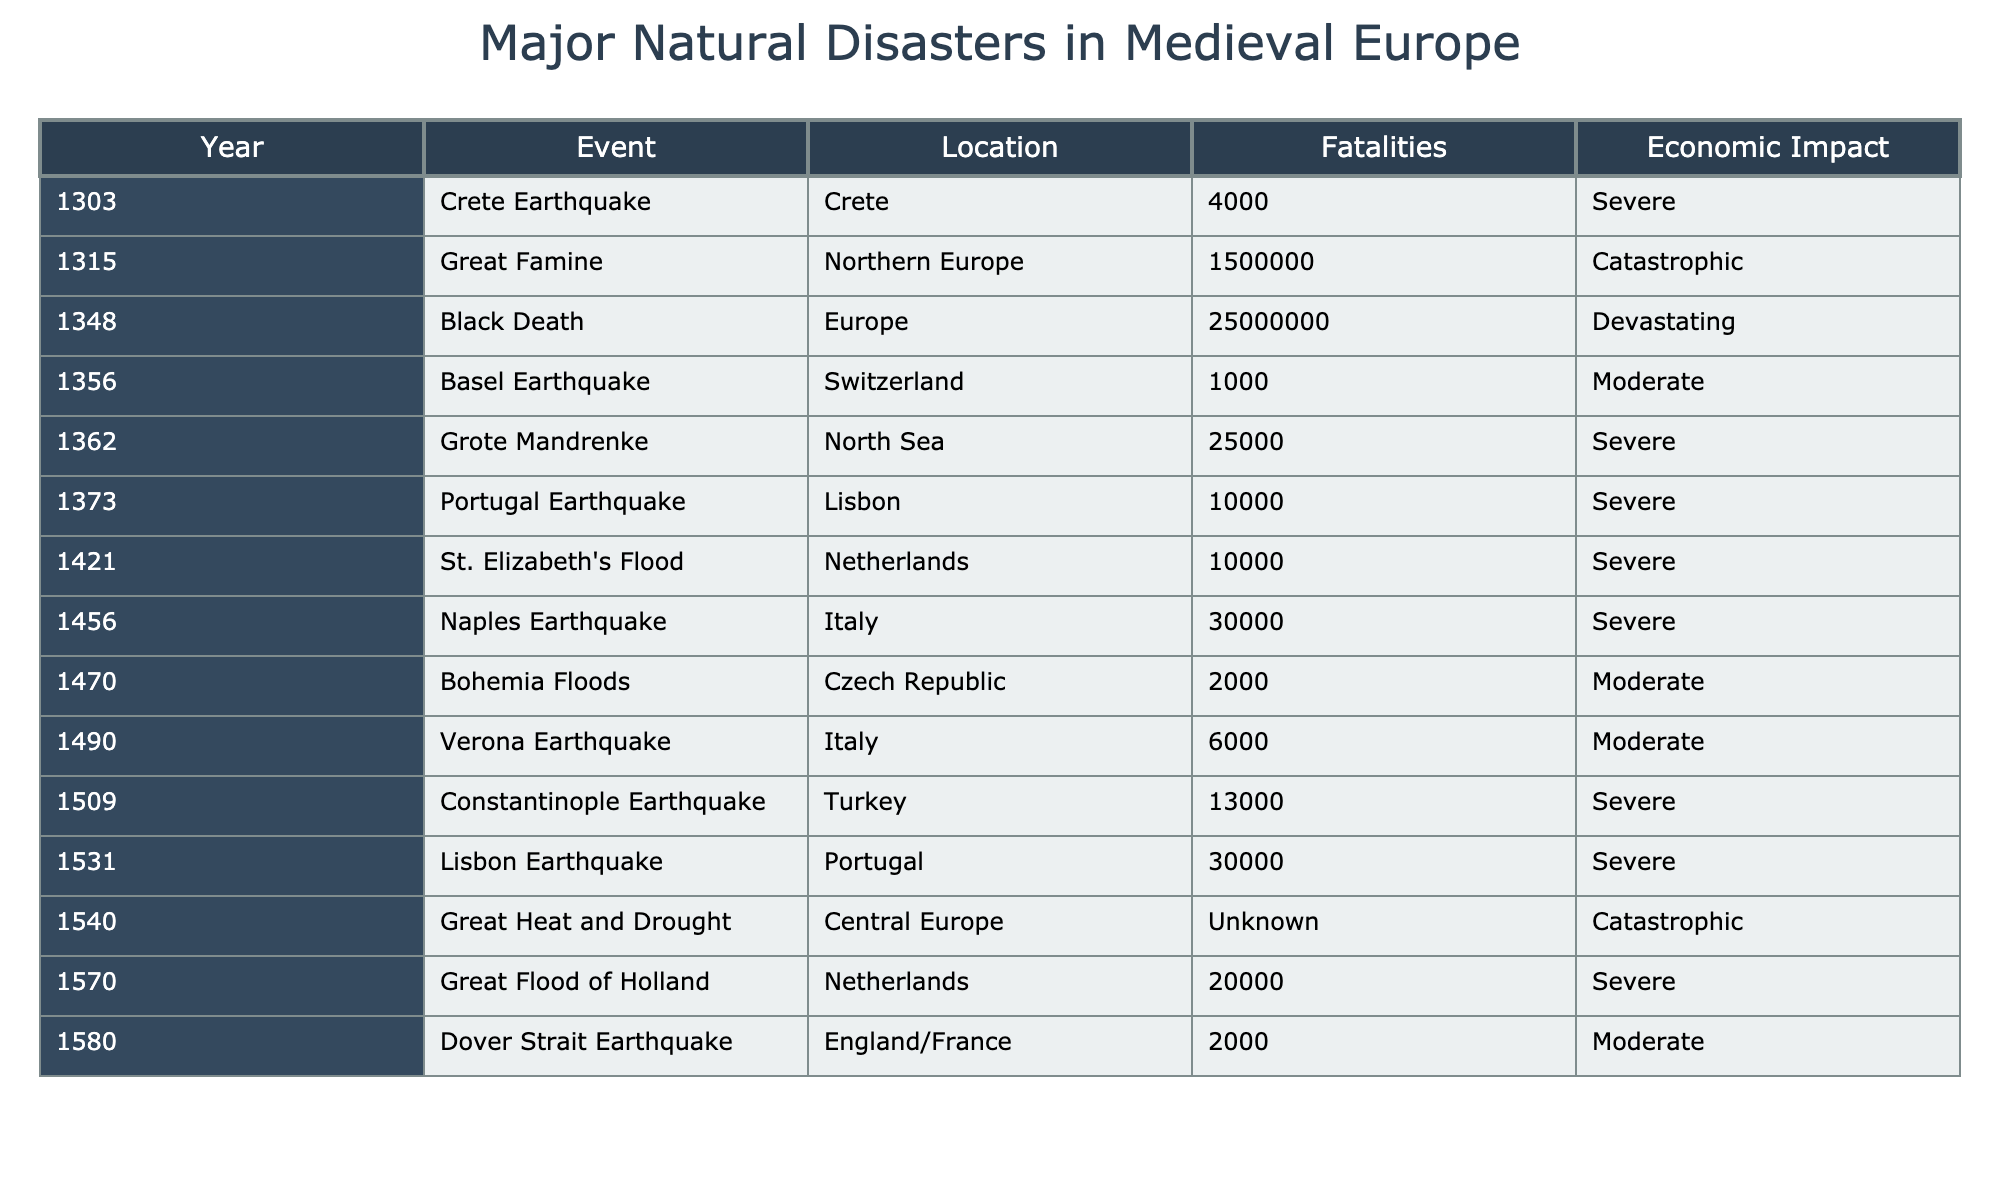What year did the Black Death occur? According to the table, the Black Death is recorded in the year 1348.
Answer: 1348 What is the total number of fatalities recorded for all events listed? By adding up the fatalities: 4000 + 1500000 + 25000000 + 1000 + 25000 + 10000 + 10000 + 30000 + 2000 + 6000 + 13000 + 30000 + Unknown (considered as 0) = 2660530.
Answer: 2660530 Which event had the highest economic impact? The event with the highest economic impact is the Great Famine, listed as Catastrophic.
Answer: Great Famine How many events caused more than 10,000 fatalities? The events causing more than 10,000 fatalities are: Great Famine (1500000), Black Death (25000000), and Lisbon Earthquake (30000). That makes a total of 3 events.
Answer: 3 Is the Great Heat and Drought listed with specific fatalities? The entry for the Great Heat and Drought has its fatalities listed as Unknown, indicating no specific number was recorded.
Answer: No How many natural disaster events occurred in the 14th century? The events that occurred in the 14th century are: Black Death (1348), Basel Earthquake (1356), and Grote Mandrenke (1362), totaling 3 events.
Answer: 3 What is the difference in fatalities between the Crete Earthquake and the Great Flood of Holland? The Crete Earthquake had 4000 fatalities, and the Great Flood of Holland had 20000, therefore, the difference is 20000 - 4000 = 16000.
Answer: 16000 Which location experienced more than one recorded disaster? The Netherlands experienced two recorded disasters: St. Elizabeth's Flood (1421) and Great Flood of Holland (1570).
Answer: Netherlands Was there any earthquake event recorded in England or France? The table lists the Dover Strait Earthquake (1580) as occurring in England/France. Therefore, there was an earthquake event in that region.
Answer: Yes What is the average number of fatalities for all recorded earthquake events? The recorded earthquake events and their fatalities are: 4000 (Crete), 1000 (Basel), 25000 (Grote Mandrenke), 10000 (Portugal), 30000 (Naples), 13000 (Constantinople), and 30000 (Lisbon). The total fatalities for these earthquakes is 4000 + 1000 + 25000 + 10000 + 30000 + 13000 + 30000 = 106000. There are 7 events, so the average is 106000 / 7 = 15142.86 (rounded to 15143).
Answer: 15143 